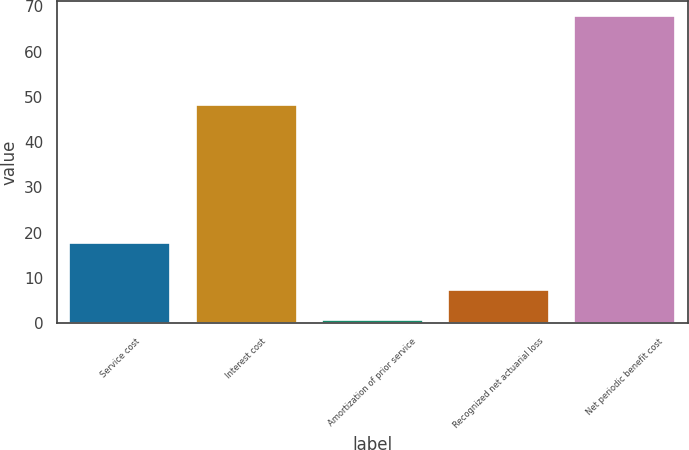Convert chart. <chart><loc_0><loc_0><loc_500><loc_500><bar_chart><fcel>Service cost<fcel>Interest cost<fcel>Amortization of prior service<fcel>Recognized net actuarial loss<fcel>Net periodic benefit cost<nl><fcel>17.8<fcel>48.2<fcel>0.7<fcel>7.41<fcel>67.8<nl></chart> 